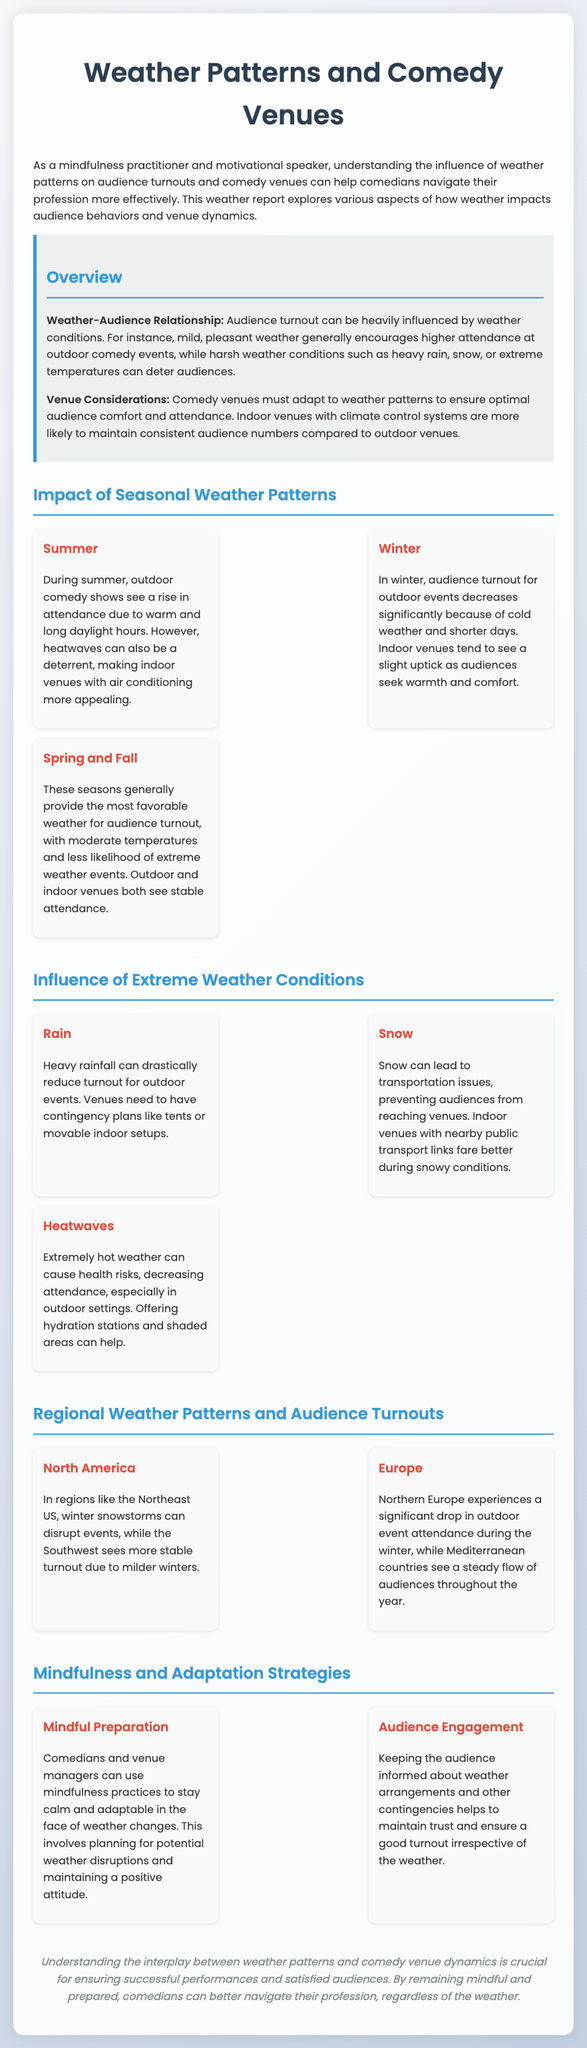What is the influence of mild weather? Mild, pleasant weather generally encourages higher attendance at outdoor comedy events.
Answer: Higher attendance What happens to audience turnout in winter? Audience turnout for outdoor events decreases significantly because of cold weather and shorter days.
Answer: Decreases significantly What is the best season for audience turnout? Spring and Fall generally provide the most favorable weather for audience turnout.
Answer: Spring and Fall How does rain affect outdoor events? Heavy rainfall can drastically reduce turnout for outdoor events.
Answer: Drastically reduce turnout What preparations can comedians use for weather changes? Comedians and venue managers can use mindfulness practices to stay calm and adaptable in the face of weather changes.
Answer: Mindfulness practices What challenges do North American regions face in winter? In regions like the Northeast US, winter snowstorms can disrupt events.
Answer: Winter snowstorms What helps maintain trust with the audience? Keeping the audience informed about weather arrangements and other contingencies helps maintain trust.
Answer: Keeping informed What happens during heatwaves at outdoor venues? Extremely hot weather can cause health risks, decreasing attendance.
Answer: Decreasing attendance 